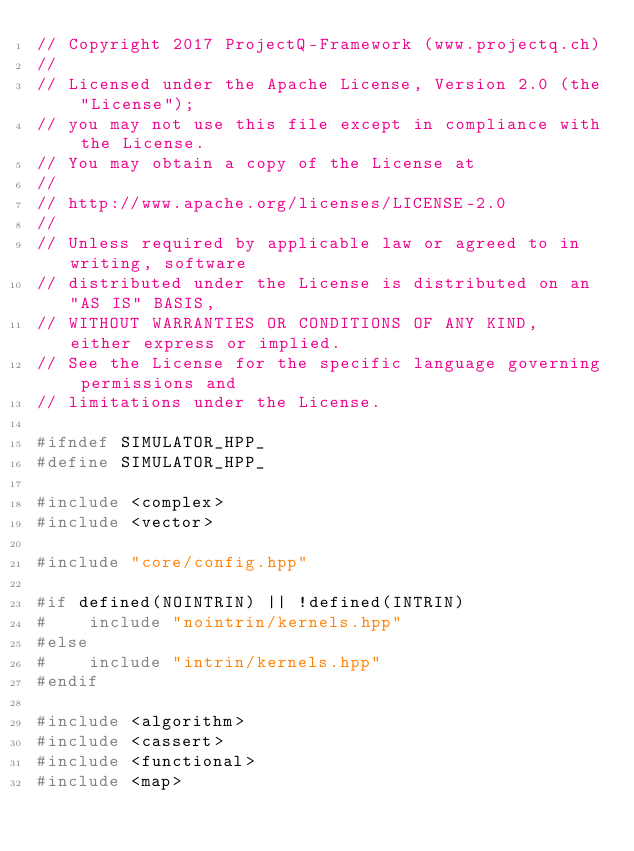<code> <loc_0><loc_0><loc_500><loc_500><_C++_>// Copyright 2017 ProjectQ-Framework (www.projectq.ch)
//
// Licensed under the Apache License, Version 2.0 (the "License");
// you may not use this file except in compliance with the License.
// You may obtain a copy of the License at
//
// http://www.apache.org/licenses/LICENSE-2.0
//
// Unless required by applicable law or agreed to in writing, software
// distributed under the License is distributed on an "AS IS" BASIS,
// WITHOUT WARRANTIES OR CONDITIONS OF ANY KIND, either express or implied.
// See the License for the specific language governing permissions and
// limitations under the License.

#ifndef SIMULATOR_HPP_
#define SIMULATOR_HPP_

#include <complex>
#include <vector>

#include "core/config.hpp"

#if defined(NOINTRIN) || !defined(INTRIN)
#    include "nointrin/kernels.hpp"
#else
#    include "intrin/kernels.hpp"
#endif

#include <algorithm>
#include <cassert>
#include <functional>
#include <map></code> 